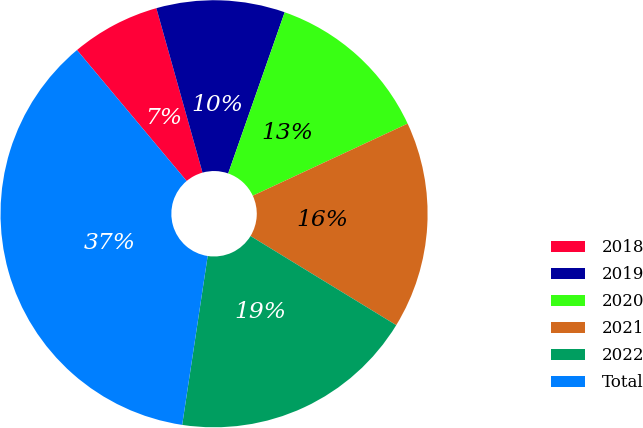Convert chart to OTSL. <chart><loc_0><loc_0><loc_500><loc_500><pie_chart><fcel>2018<fcel>2019<fcel>2020<fcel>2021<fcel>2022<fcel>Total<nl><fcel>6.74%<fcel>9.72%<fcel>12.7%<fcel>15.67%<fcel>18.65%<fcel>36.52%<nl></chart> 